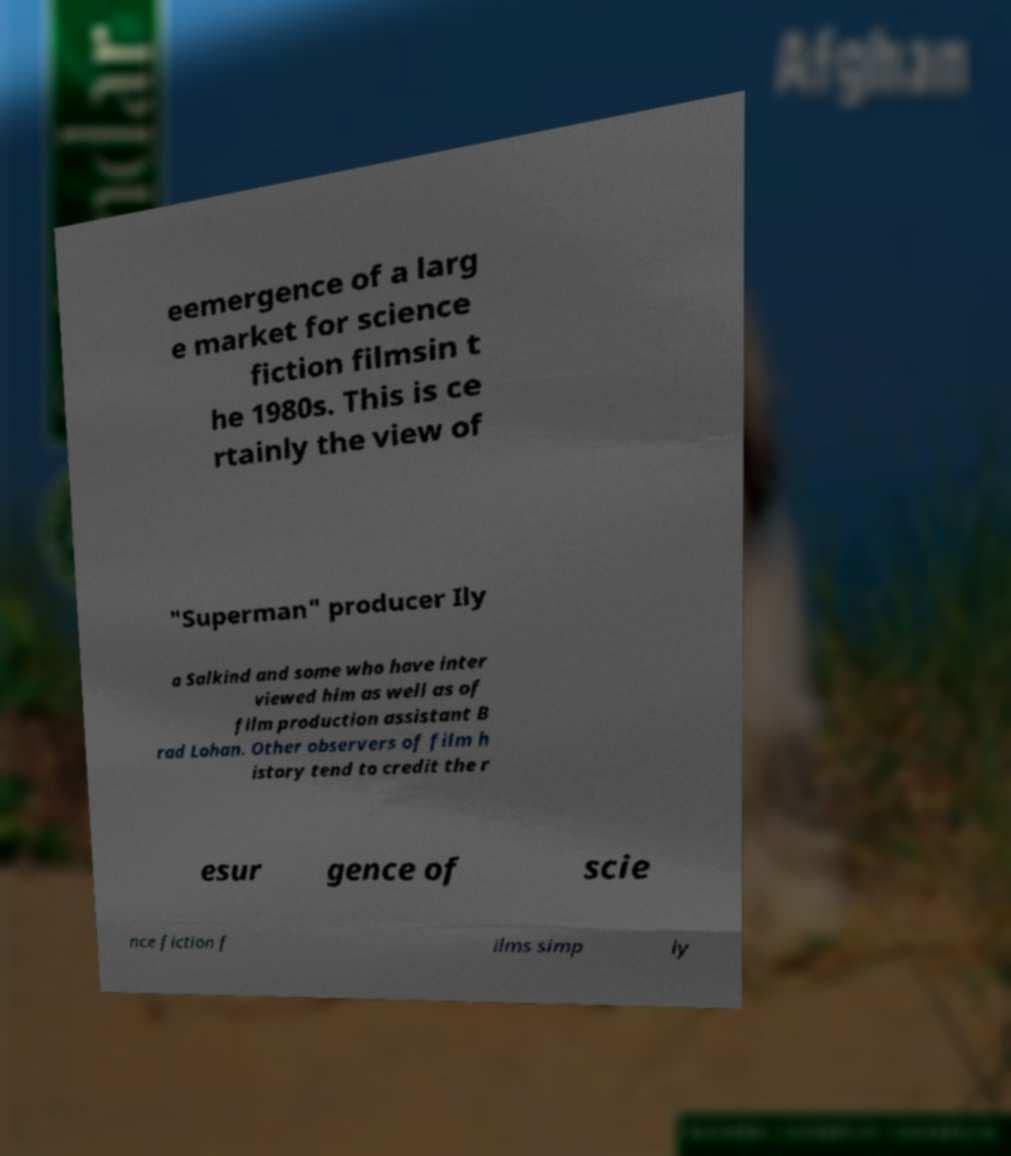What messages or text are displayed in this image? I need them in a readable, typed format. eemergence of a larg e market for science fiction filmsin t he 1980s. This is ce rtainly the view of "Superman" producer Ily a Salkind and some who have inter viewed him as well as of film production assistant B rad Lohan. Other observers of film h istory tend to credit the r esur gence of scie nce fiction f ilms simp ly 